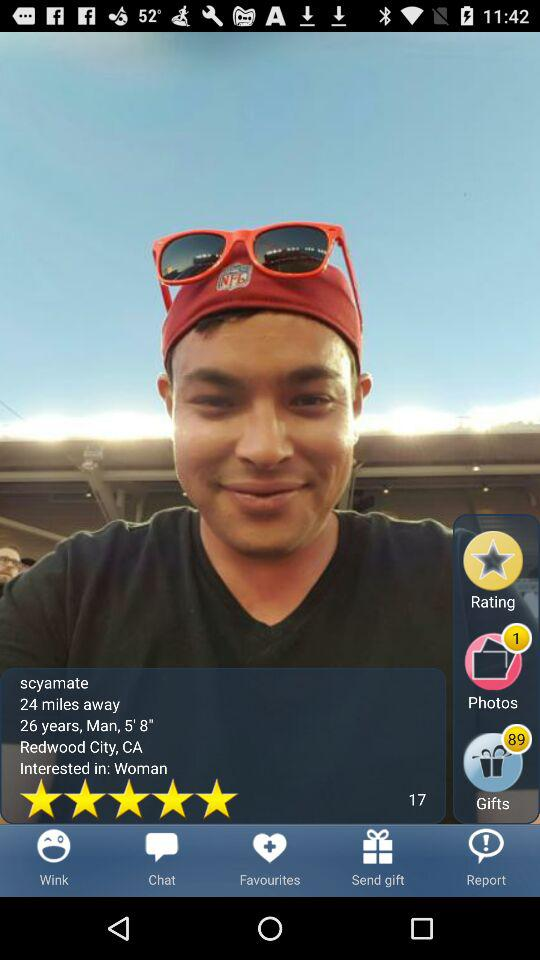What is the count of gifts? The gift count is 89. 